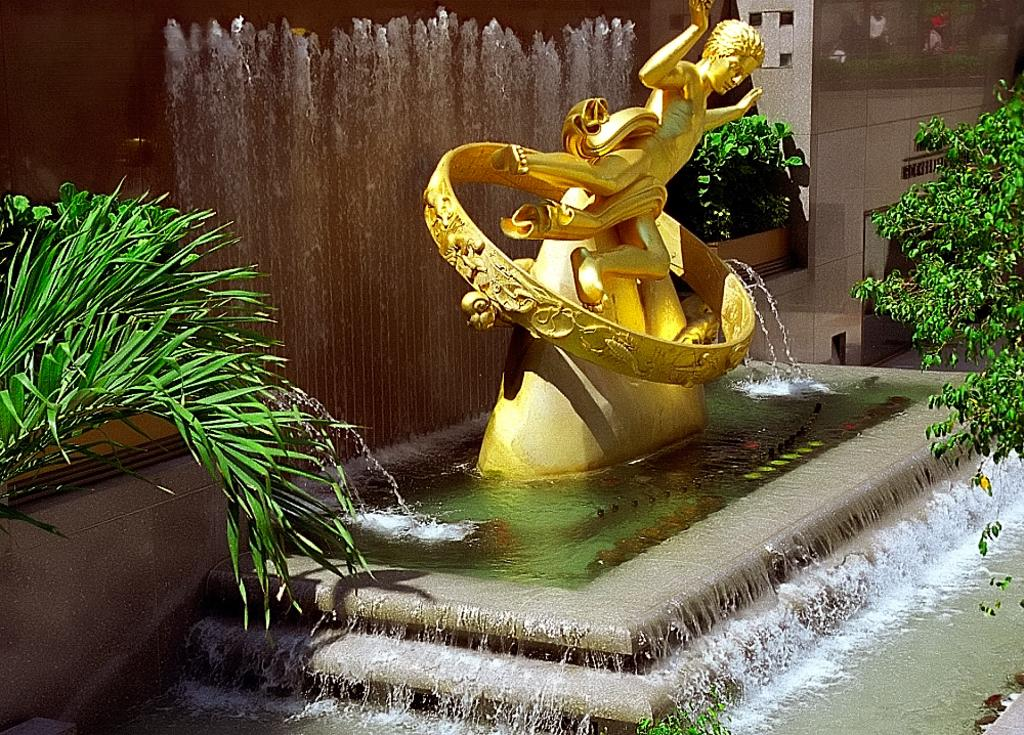What is the main subject in the center of the image? There is a golden color sculpture in the center of the image. What is the sculpture surrounded by? There is water surrounding the sculpture. What type of vegetation can be seen on both sides of the image? There are plants on both sides of the image. What can be seen in the background of the image? There are plants visible in the background of the image. What degree of heat is the tiger experiencing in the image? There is no tiger present in the image, so it is not possible to determine the degree of heat it might be experiencing. 